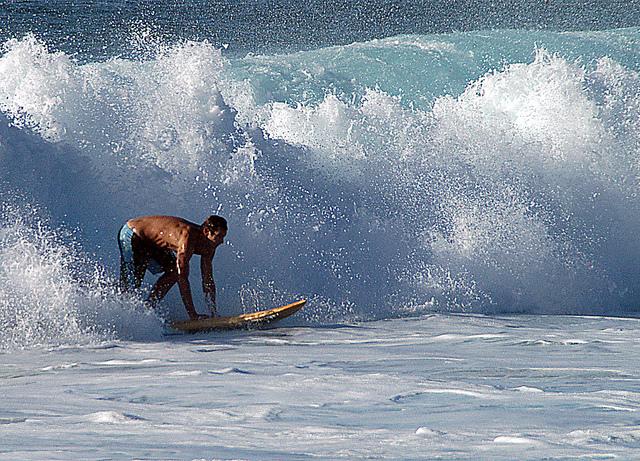Does the man on the surfboard have a shirt on?
Be succinct. No. What color is the man's surfboard?
Keep it brief. Yellow. Is he having fun?
Keep it brief. Yes. 